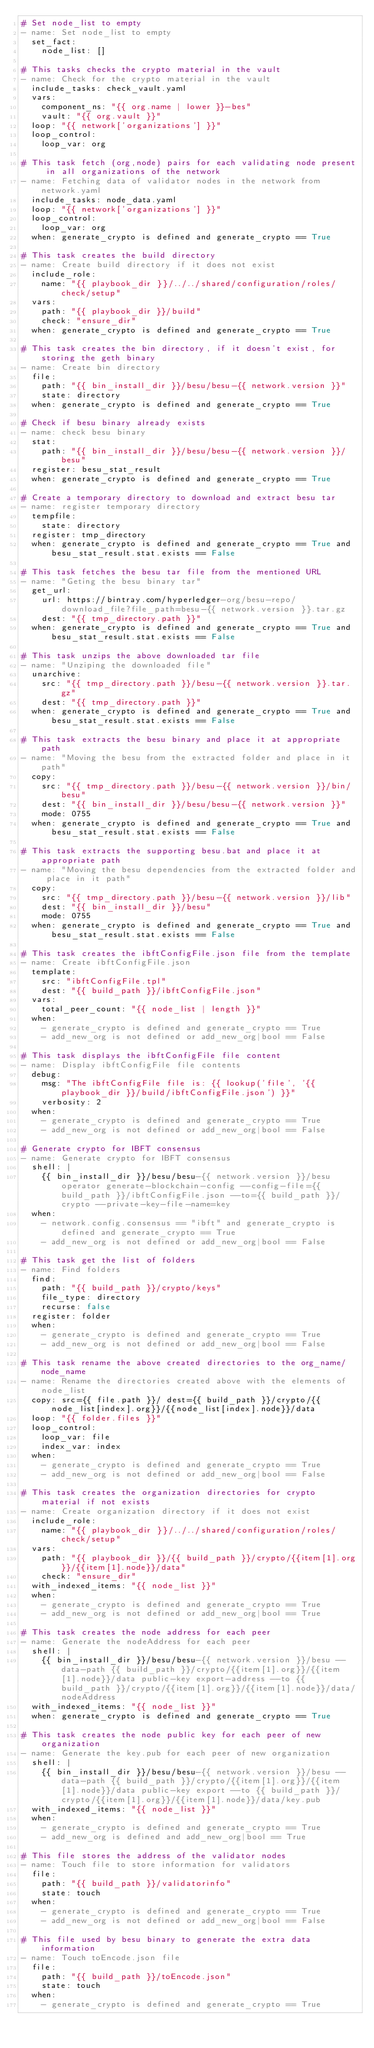<code> <loc_0><loc_0><loc_500><loc_500><_YAML_># Set node_list to empty
- name: Set node_list to empty
  set_fact:
    node_list: []

# This tasks checks the crypto material in the vault
- name: Check for the crypto material in the vault
  include_tasks: check_vault.yaml
  vars:
    component_ns: "{{ org.name | lower }}-bes"
    vault: "{{ org.vault }}"
  loop: "{{ network['organizations'] }}"
  loop_control:
    loop_var: org

# This task fetch (org,node) pairs for each validating node present in all organizations of the network
- name: Fetching data of validator nodes in the network from network.yaml
  include_tasks: node_data.yaml
  loop: "{{ network['organizations'] }}"
  loop_control:
    loop_var: org
  when: generate_crypto is defined and generate_crypto == True

# This task creates the build directory
- name: Create build directory if it does not exist
  include_role:
    name: "{{ playbook_dir }}/../../shared/configuration/roles/check/setup"
  vars:
    path: "{{ playbook_dir }}/build"
    check: "ensure_dir"
  when: generate_crypto is defined and generate_crypto == True

# This task creates the bin directory, if it doesn't exist, for storing the geth binary
- name: Create bin directory
  file:
    path: "{{ bin_install_dir }}/besu/besu-{{ network.version }}"
    state: directory
  when: generate_crypto is defined and generate_crypto == True

# Check if besu binary already exists
- name: check besu binary
  stat:
    path: "{{ bin_install_dir }}/besu/besu-{{ network.version }}/besu"
  register: besu_stat_result
  when: generate_crypto is defined and generate_crypto == True

# Create a temporary directory to download and extract besu tar
- name: register temporary directory
  tempfile:
    state: directory
  register: tmp_directory
  when: generate_crypto is defined and generate_crypto == True and besu_stat_result.stat.exists == False

# This task fetches the besu tar file from the mentioned URL
- name: "Geting the besu binary tar"
  get_url:
    url: https://bintray.com/hyperledger-org/besu-repo/download_file?file_path=besu-{{ network.version }}.tar.gz
    dest: "{{ tmp_directory.path }}"
  when: generate_crypto is defined and generate_crypto == True and besu_stat_result.stat.exists == False

# This task unzips the above downloaded tar file
- name: "Unziping the downloaded file"
  unarchive:
    src: "{{ tmp_directory.path }}/besu-{{ network.version }}.tar.gz"
    dest: "{{ tmp_directory.path }}"
  when: generate_crypto is defined and generate_crypto == True and besu_stat_result.stat.exists == False

# This task extracts the besu binary and place it at appropriate path
- name: "Moving the besu from the extracted folder and place in it path"
  copy:
    src: "{{ tmp_directory.path }}/besu-{{ network.version }}/bin/besu"
    dest: "{{ bin_install_dir }}/besu/besu-{{ network.version }}"
    mode: 0755
  when: generate_crypto is defined and generate_crypto == True and besu_stat_result.stat.exists == False

# This task extracts the supporting besu.bat and place it at appropriate path
- name: "Moving the besu dependencies from the extracted folder and place in it path"
  copy:
    src: "{{ tmp_directory.path }}/besu-{{ network.version }}/lib"
    dest: "{{ bin_install_dir }}/besu"
    mode: 0755
  when: generate_crypto is defined and generate_crypto == True and besu_stat_result.stat.exists == False

# This task creates the ibftConfigFile.json file from the template
- name: Create ibftConfigFile.json
  template:
    src: "ibftConfigFile.tpl"
    dest: "{{ build_path }}/ibftConfigFile.json"
  vars:
    total_peer_count: "{{ node_list | length }}"
  when: 
    - generate_crypto is defined and generate_crypto == True
    - add_new_org is not defined or add_new_org|bool == False

# This task displays the ibftConfigFile file content
- name: Display ibftConfigFile file contents
  debug: 
    msg: "The ibftConfigFile file is: {{ lookup('file', '{{ playbook_dir }}/build/ibftConfigFile.json') }}"
    verbosity: 2
  when: 
    - generate_crypto is defined and generate_crypto == True
    - add_new_org is not defined or add_new_org|bool == False

# Generate crypto for IBFT consensus
- name: Generate crypto for IBFT consensus
  shell: |
    {{ bin_install_dir }}/besu/besu-{{ network.version }}/besu operator generate-blockchain-config --config-file={{ build_path }}/ibftConfigFile.json --to={{ build_path }}/crypto --private-key-file-name=key
  when: 
    - network.config.consensus == "ibft" and generate_crypto is defined and generate_crypto == True
    - add_new_org is not defined or add_new_org|bool == False

# This task get the list of folders
- name: Find folders
  find:
    path: "{{ build_path }}/crypto/keys"
    file_type: directory
    recurse: false
  register: folder
  when: 
    - generate_crypto is defined and generate_crypto == True
    - add_new_org is not defined or add_new_org|bool == False

# This task rename the above created directories to the org_name/node_name 
- name: Rename the directories created above with the elements of node_list
  copy: src={{ file.path }}/ dest={{ build_path }}/crypto/{{node_list[index].org}}/{{node_list[index].node}}/data
  loop: "{{ folder.files }}"
  loop_control:
    loop_var: file
    index_var: index
  when: 
    - generate_crypto is defined and generate_crypto == True
    - add_new_org is not defined or add_new_org|bool == False

# This task creates the organization directories for crypto material if not exists
- name: Create organization directory if it does not exist
  include_role:
    name: "{{ playbook_dir }}/../../shared/configuration/roles/check/setup"
  vars:
    path: "{{ playbook_dir }}/{{ build_path }}/crypto/{{item[1].org}}/{{item[1].node}}/data"
    check: "ensure_dir"
  with_indexed_items: "{{ node_list }}"
  when:  
    - generate_crypto is defined and generate_crypto == True
    - add_new_org is not defined or add_new_org|bool == True

# This task creates the node address for each peer 
- name: Generate the nodeAddress for each peer
  shell: |
    {{ bin_install_dir }}/besu/besu-{{ network.version }}/besu --data-path {{ build_path }}/crypto/{{item[1].org}}/{{item[1].node}}/data public-key export-address --to {{ build_path }}/crypto/{{item[1].org}}/{{item[1].node}}/data/nodeAddress
  with_indexed_items: "{{ node_list }}"
  when: generate_crypto is defined and generate_crypto == True

# This task creates the node public key for each peer of new organization 
- name: Generate the key.pub for each peer of new organization
  shell: |
    {{ bin_install_dir }}/besu/besu-{{ network.version }}/besu --data-path {{ build_path }}/crypto/{{item[1].org}}/{{item[1].node}}/data public-key export --to {{ build_path }}/crypto/{{item[1].org}}/{{item[1].node}}/data/key.pub
  with_indexed_items: "{{ node_list }}"
  when:  
    - generate_crypto is defined and generate_crypto == True
    - add_new_org is defined and add_new_org|bool == True

# This file stores the address of the validator nodes
- name: Touch file to store information for validators
  file:
    path: "{{ build_path }}/validatorinfo"
    state: touch
  when:  
    - generate_crypto is defined and generate_crypto == True
    - add_new_org is not defined or add_new_org|bool == False

# This file used by besu binary to generate the extra data information
- name: Touch toEncode.json file
  file:
    path: "{{ build_path }}/toEncode.json"
    state: touch
  when:  
    - generate_crypto is defined and generate_crypto == True</code> 